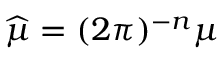<formula> <loc_0><loc_0><loc_500><loc_500>{ \widehat { \mu } } = ( 2 \pi ) ^ { - n } \mu</formula> 